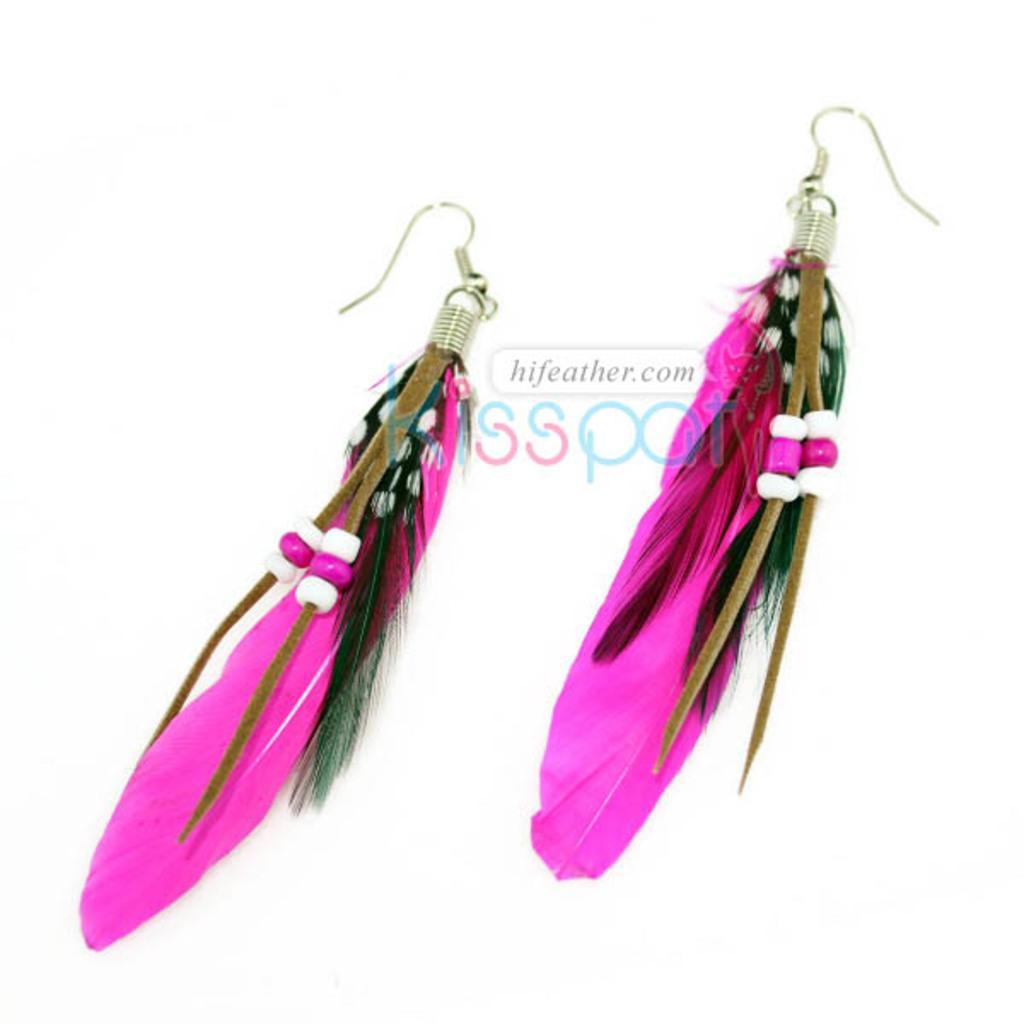Please provide a concise description of this image. Here in this picture we can see earrings with pink colored feathers present over a place. 